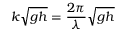<formula> <loc_0><loc_0><loc_500><loc_500>k { \sqrt { g h } } = { \frac { 2 \pi } { \lambda } } { \sqrt { g h } }</formula> 